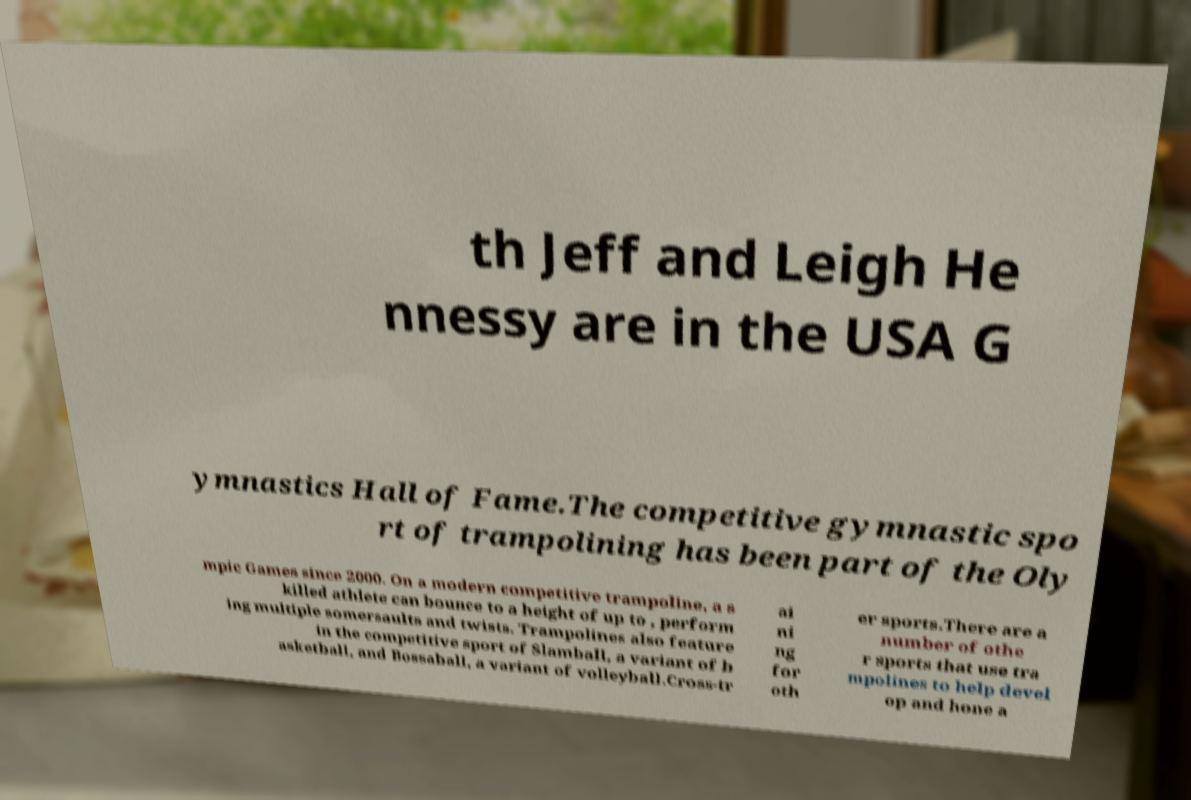For documentation purposes, I need the text within this image transcribed. Could you provide that? th Jeff and Leigh He nnessy are in the USA G ymnastics Hall of Fame.The competitive gymnastic spo rt of trampolining has been part of the Oly mpic Games since 2000. On a modern competitive trampoline, a s killed athlete can bounce to a height of up to , perform ing multiple somersaults and twists. Trampolines also feature in the competitive sport of Slamball, a variant of b asketball, and Bossaball, a variant of volleyball.Cross-tr ai ni ng for oth er sports.There are a number of othe r sports that use tra mpolines to help devel op and hone a 